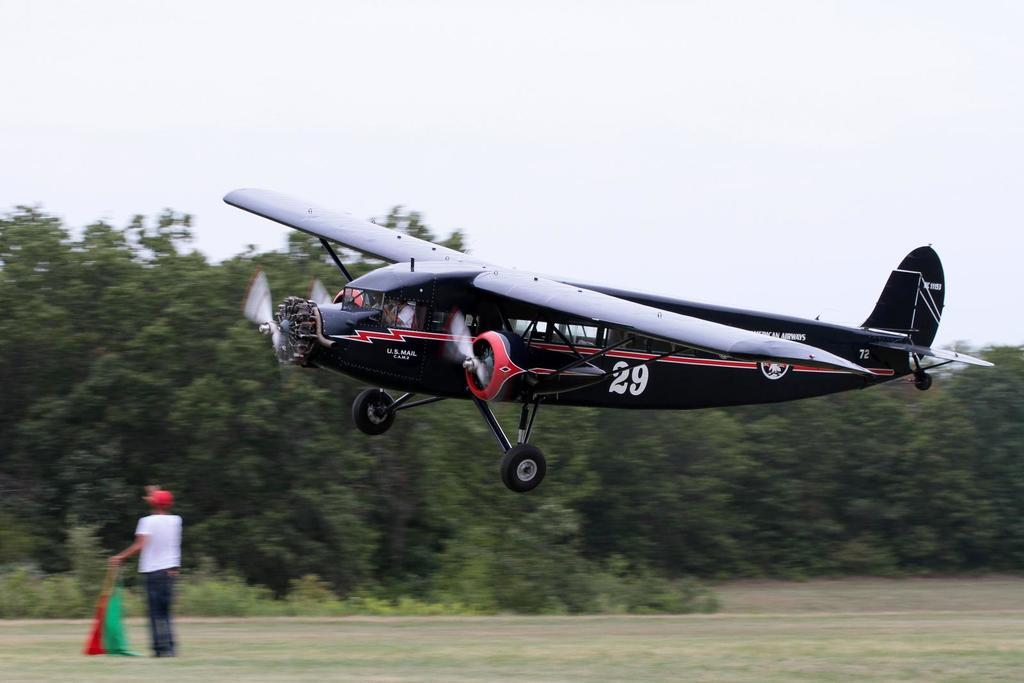What is the main subject of the image? The main subject of the image is an airplane. Can you describe the position of the airplane in the image? The airplane is in the air in the image. What can be seen in the background of the image? In the background of the image, there is a person holding flags, grass, trees, and the sky. How many writers are visible in the image? There are no writers present in the image. What type of fight can be seen taking place in the image? There is no fight present in the image; it features an airplane in the air and a person holding flags in the background. 